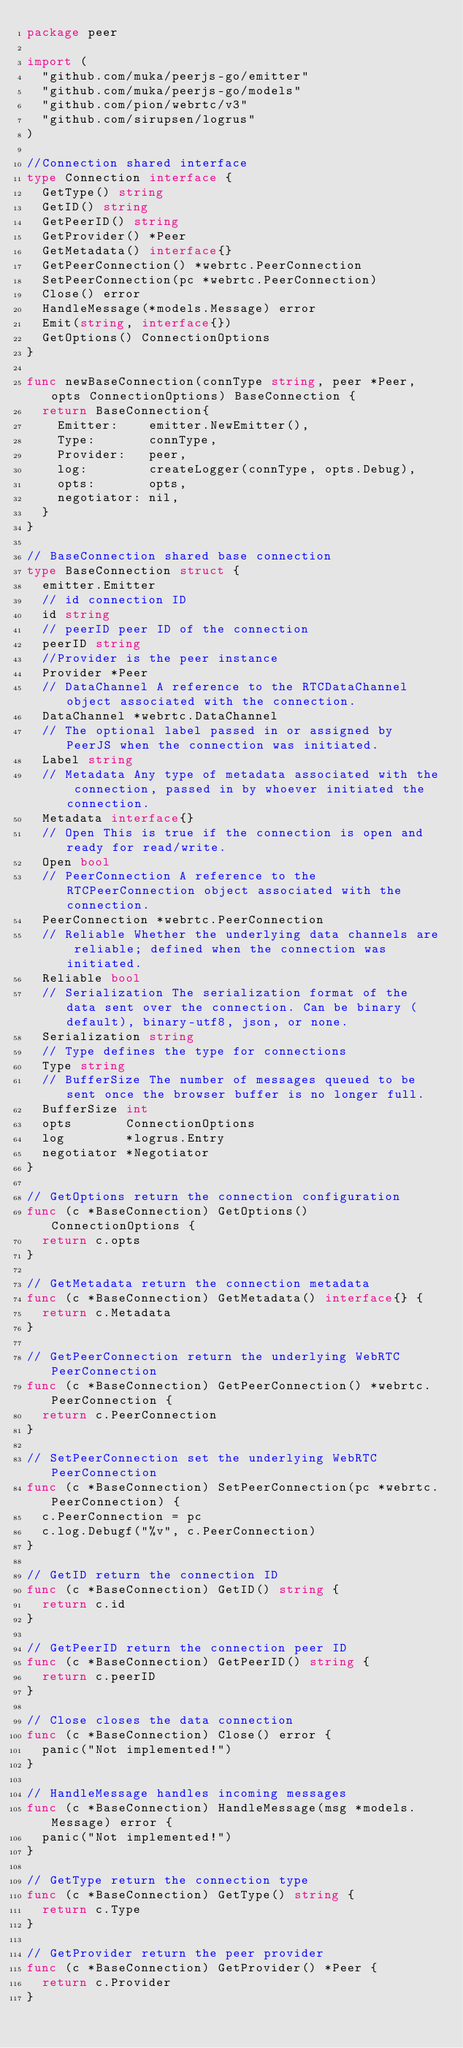<code> <loc_0><loc_0><loc_500><loc_500><_Go_>package peer

import (
	"github.com/muka/peerjs-go/emitter"
	"github.com/muka/peerjs-go/models"
	"github.com/pion/webrtc/v3"
	"github.com/sirupsen/logrus"
)

//Connection shared interface
type Connection interface {
	GetType() string
	GetID() string
	GetPeerID() string
	GetProvider() *Peer
	GetMetadata() interface{}
	GetPeerConnection() *webrtc.PeerConnection
	SetPeerConnection(pc *webrtc.PeerConnection)
	Close() error
	HandleMessage(*models.Message) error
	Emit(string, interface{})
	GetOptions() ConnectionOptions
}

func newBaseConnection(connType string, peer *Peer, opts ConnectionOptions) BaseConnection {
	return BaseConnection{
		Emitter:    emitter.NewEmitter(),
		Type:       connType,
		Provider:   peer,
		log:        createLogger(connType, opts.Debug),
		opts:       opts,
		negotiator: nil,
	}
}

// BaseConnection shared base connection
type BaseConnection struct {
	emitter.Emitter
	// id connection ID
	id string
	// peerID peer ID of the connection
	peerID string
	//Provider is the peer instance
	Provider *Peer
	// DataChannel A reference to the RTCDataChannel object associated with the connection.
	DataChannel *webrtc.DataChannel
	// The optional label passed in or assigned by PeerJS when the connection was initiated.
	Label string
	// Metadata Any type of metadata associated with the connection, passed in by whoever initiated the connection.
	Metadata interface{}
	// Open This is true if the connection is open and ready for read/write.
	Open bool
	// PeerConnection A reference to the RTCPeerConnection object associated with the connection.
	PeerConnection *webrtc.PeerConnection
	// Reliable Whether the underlying data channels are reliable; defined when the connection was initiated.
	Reliable bool
	// Serialization The serialization format of the data sent over the connection. Can be binary (default), binary-utf8, json, or none.
	Serialization string
	// Type defines the type for connections
	Type string
	// BufferSize The number of messages queued to be sent once the browser buffer is no longer full.
	BufferSize int
	opts       ConnectionOptions
	log        *logrus.Entry
	negotiator *Negotiator
}

// GetOptions return the connection configuration
func (c *BaseConnection) GetOptions() ConnectionOptions {
	return c.opts
}

// GetMetadata return the connection metadata
func (c *BaseConnection) GetMetadata() interface{} {
	return c.Metadata
}

// GetPeerConnection return the underlying WebRTC PeerConnection
func (c *BaseConnection) GetPeerConnection() *webrtc.PeerConnection {
	return c.PeerConnection
}

// SetPeerConnection set the underlying WebRTC PeerConnection
func (c *BaseConnection) SetPeerConnection(pc *webrtc.PeerConnection) {
	c.PeerConnection = pc
	c.log.Debugf("%v", c.PeerConnection)
}

// GetID return the connection ID
func (c *BaseConnection) GetID() string {
	return c.id
}

// GetPeerID return the connection peer ID
func (c *BaseConnection) GetPeerID() string {
	return c.peerID
}

// Close closes the data connection
func (c *BaseConnection) Close() error {
	panic("Not implemented!")
}

// HandleMessage handles incoming messages
func (c *BaseConnection) HandleMessage(msg *models.Message) error {
	panic("Not implemented!")
}

// GetType return the connection type
func (c *BaseConnection) GetType() string {
	return c.Type
}

// GetProvider return the peer provider
func (c *BaseConnection) GetProvider() *Peer {
	return c.Provider
}
</code> 